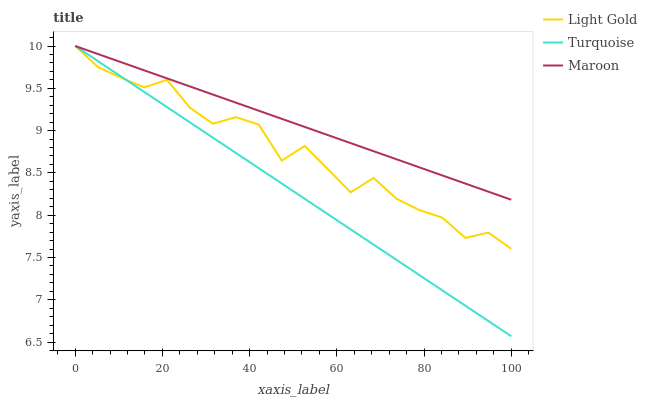Does Turquoise have the minimum area under the curve?
Answer yes or no. Yes. Does Maroon have the maximum area under the curve?
Answer yes or no. Yes. Does Light Gold have the minimum area under the curve?
Answer yes or no. No. Does Light Gold have the maximum area under the curve?
Answer yes or no. No. Is Turquoise the smoothest?
Answer yes or no. Yes. Is Light Gold the roughest?
Answer yes or no. Yes. Is Maroon the smoothest?
Answer yes or no. No. Is Maroon the roughest?
Answer yes or no. No. Does Light Gold have the lowest value?
Answer yes or no. No. Does Maroon have the highest value?
Answer yes or no. Yes. Does Turquoise intersect Light Gold?
Answer yes or no. Yes. Is Turquoise less than Light Gold?
Answer yes or no. No. Is Turquoise greater than Light Gold?
Answer yes or no. No. 